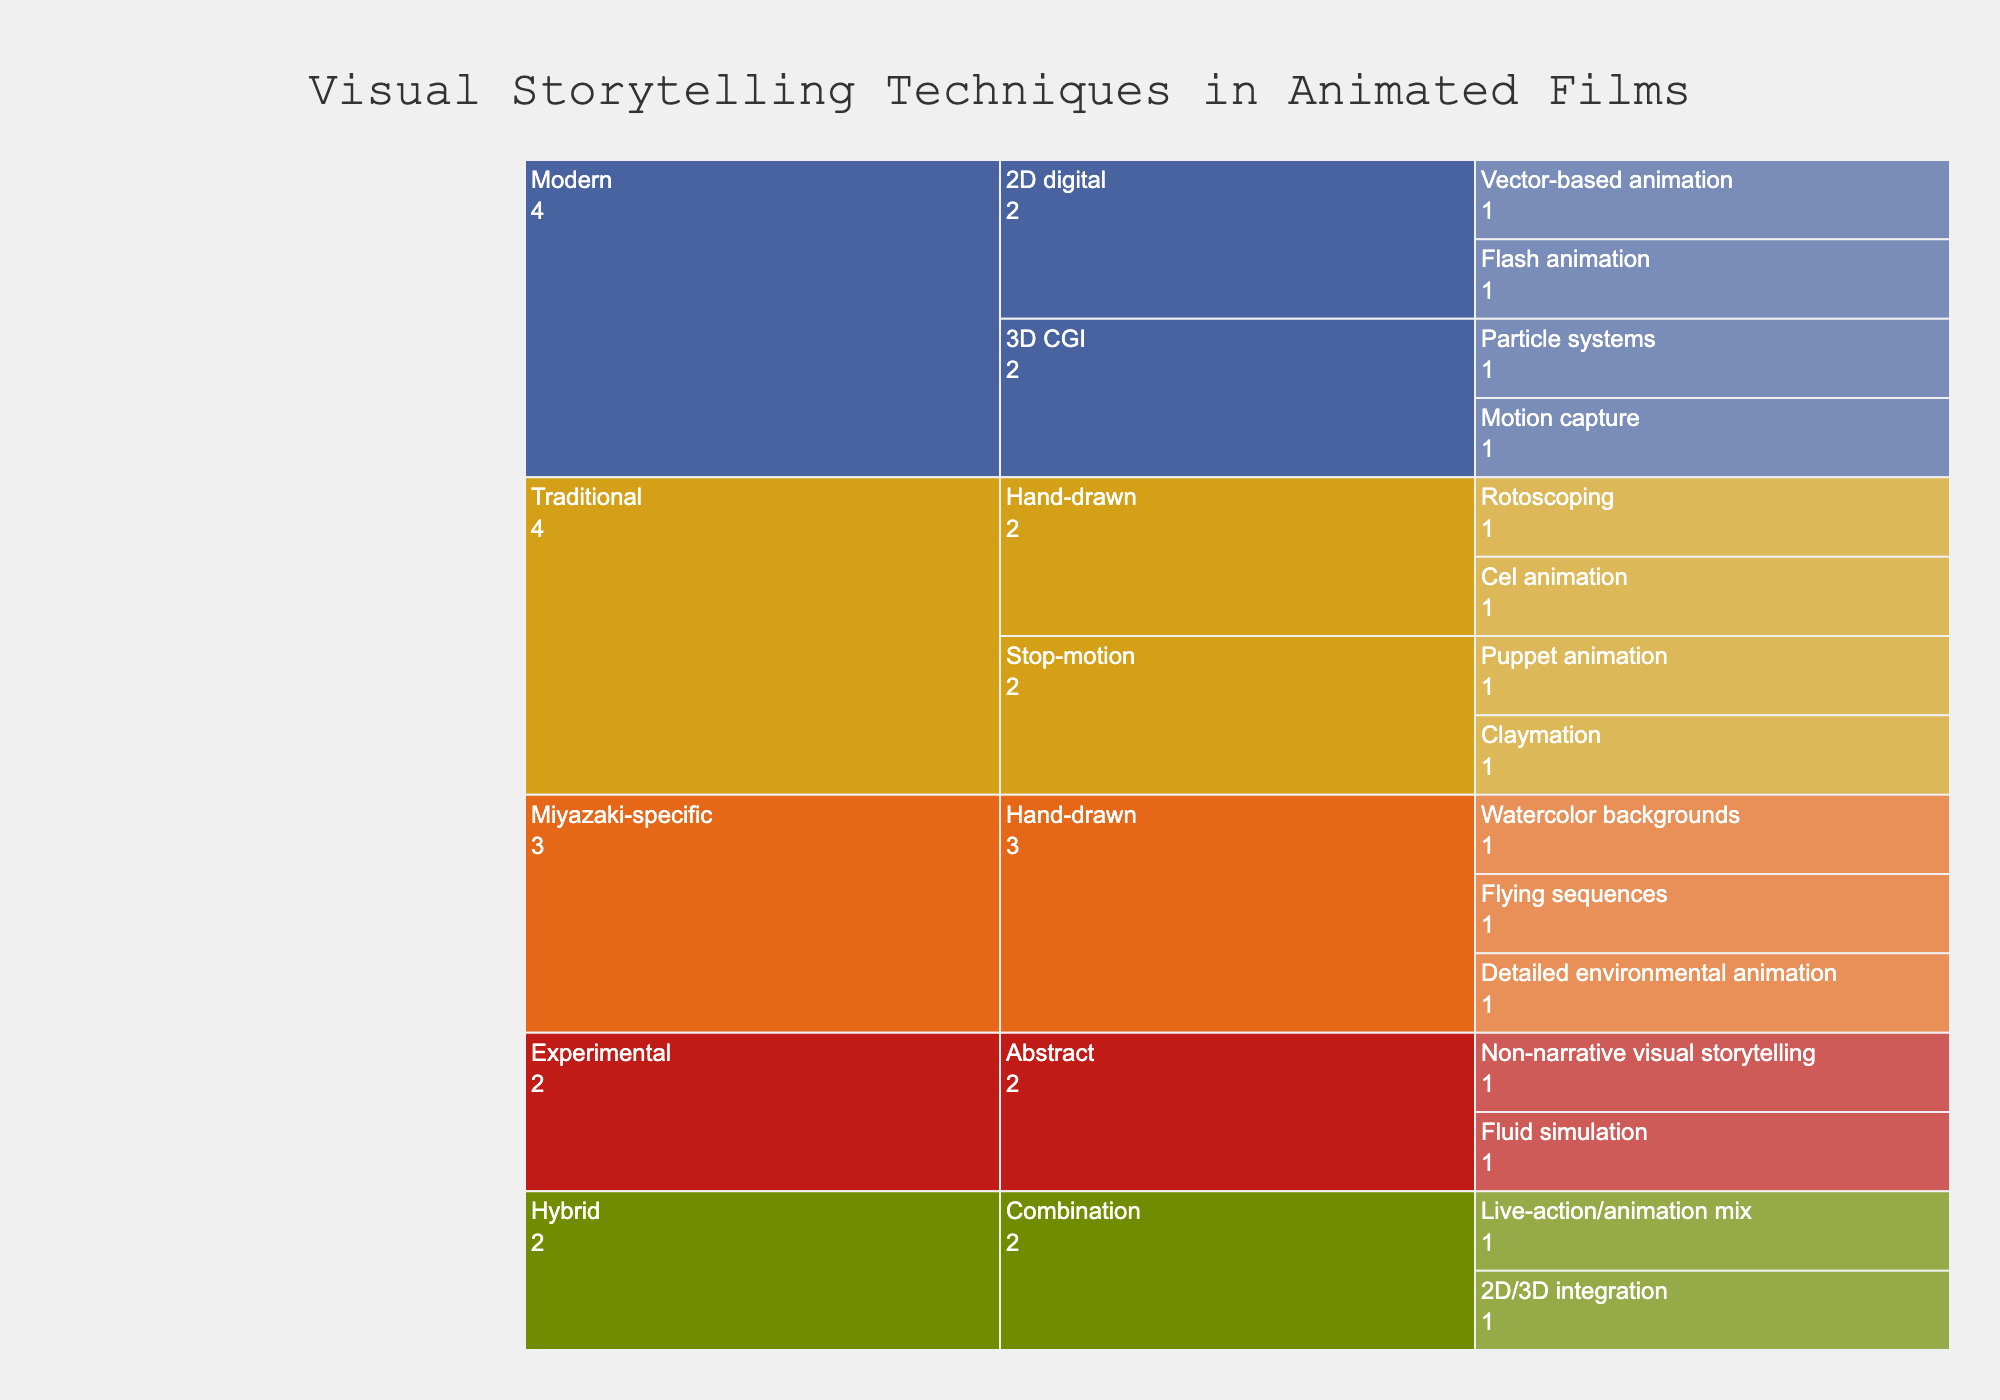What is the title of the icicle chart? The title is displayed at the top of the chart. It provides context about what the chart is depicting. In this case, it indicates that the chart shows "Visual Storytelling Techniques in Animated Films".
Answer: Visual Storytelling Techniques in Animated Films How many categories are presented in the chart? The categories are the top-level divisions in the chart, indicated by different colors. By counting these top-level divisions, we can see there are five categories.
Answer: Five Which category has the most subcategories? By observing the subdivisions of each category, we can see that the "Traditional" category has two subcategories: Hand-drawn and Stop-motion, whereas other categories mainly have one subcategory.
Answer: Traditional Name two techniques under the "Experimental" category. Each technique is listed under its respective category and subcategory. Under the "Experimental" category, there are "Non-narrative visual storytelling" and "Fluid simulation".
Answer: Non-narrative visual storytelling, Fluid simulation Which category uses the color closest to red? The colors are visually distinguishable, with "Experimental" being of a red hue among the categories depicted in the chart.
Answer: Experimental What animation technique is listed under both "Hybrid" and "Miyazaki-specific" categories? By comparing the techniques listed under both categories, we can see that there is no animation technique overlap between "Hybrid" and "Miyazaki-specific" categories.
Answer: None How many techniques are there in the "Miyazaki-specific" category? By counting each technique listed under the "Miyazaki-specific" category, we find that there are three techniques.
Answer: Three Which technique is found in the "Modern" 3D CGI subcategory? Checking under the "Modern" category and within the 3D CGI subcategory, we find the techniques "Motion capture" and "Particle systems".
Answer: Motion capture, Particle systems What is the total number of techniques listed in the chart? By counting each technique listed under all the categories and subcategories, we sum up a total of 14 techniques.
Answer: Fourteen Are there more techniques under "Hand-drawn" or "Stop-motion" in the "Traditional" category? By looking into the "Traditional" category, we count two techniques under "Hand-drawn" and two under "Stop-motion". Since both have an equal number of techniques, neither has more.
Answer: Neither 